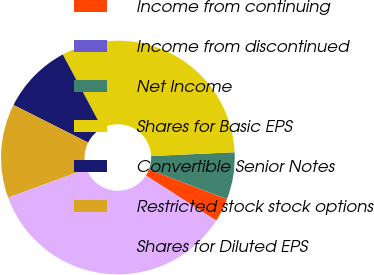Convert chart to OTSL. <chart><loc_0><loc_0><loc_500><loc_500><pie_chart><fcel>Income from continuing<fcel>Income from discontinued<fcel>Net Income<fcel>Shares for Basic EPS<fcel>Convertible Senior Notes<fcel>Restricted stock stock options<fcel>Shares for Diluted EPS<nl><fcel>3.27%<fcel>0.02%<fcel>6.51%<fcel>32.09%<fcel>9.76%<fcel>13.0%<fcel>35.34%<nl></chart> 